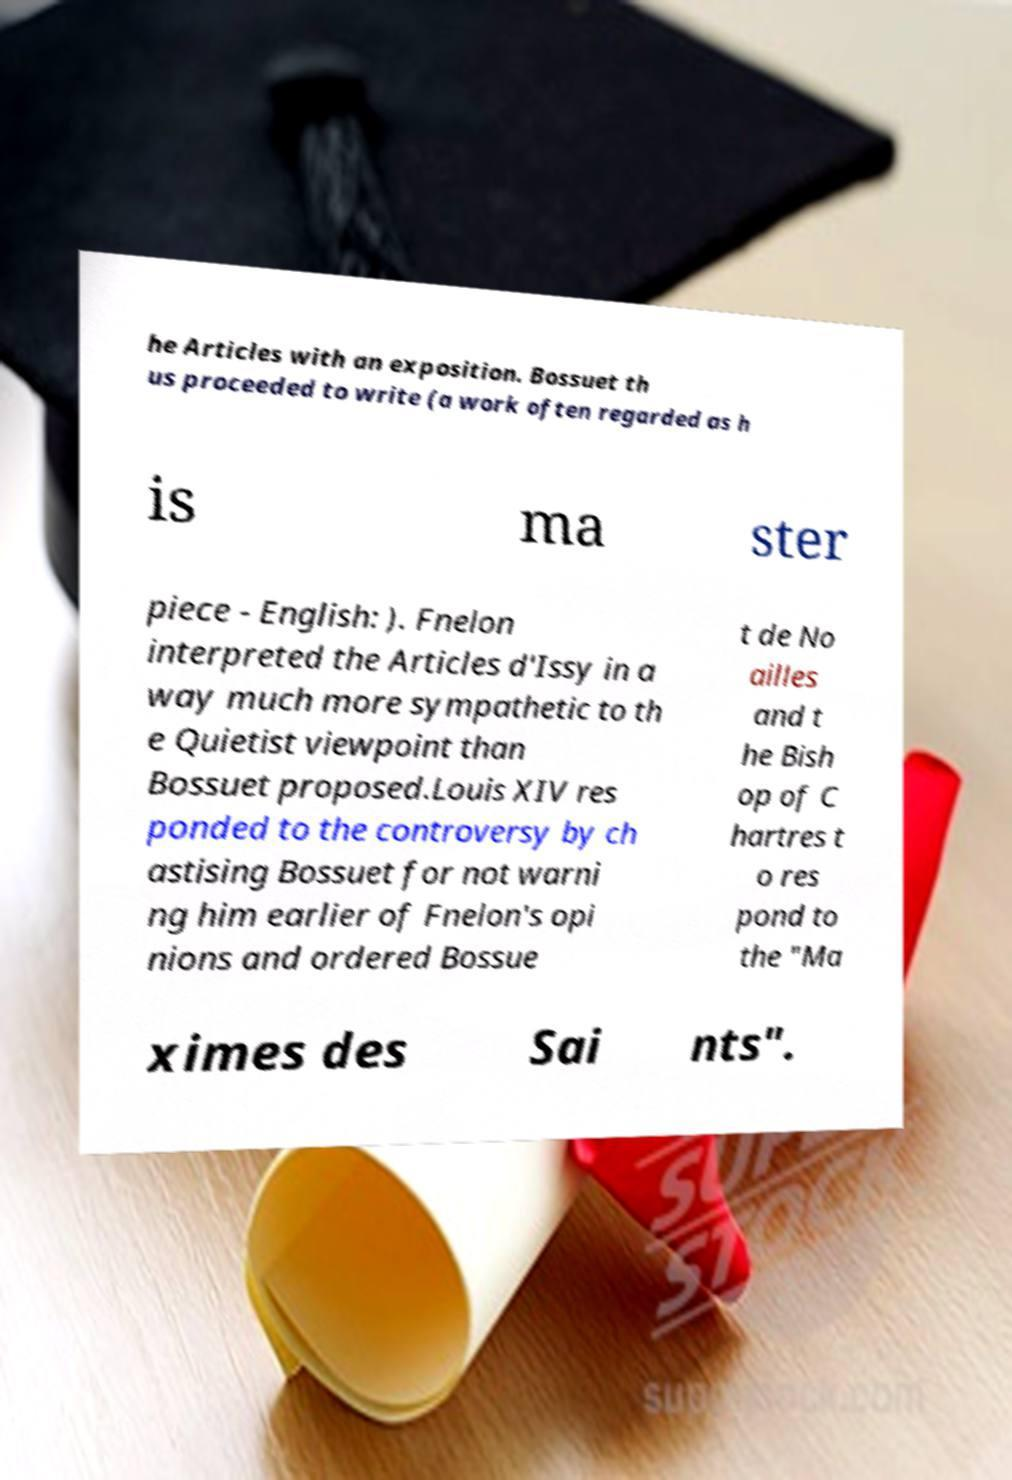Could you assist in decoding the text presented in this image and type it out clearly? he Articles with an exposition. Bossuet th us proceeded to write (a work often regarded as h is ma ster piece - English: ). Fnelon interpreted the Articles d'Issy in a way much more sympathetic to th e Quietist viewpoint than Bossuet proposed.Louis XIV res ponded to the controversy by ch astising Bossuet for not warni ng him earlier of Fnelon's opi nions and ordered Bossue t de No ailles and t he Bish op of C hartres t o res pond to the "Ma ximes des Sai nts". 